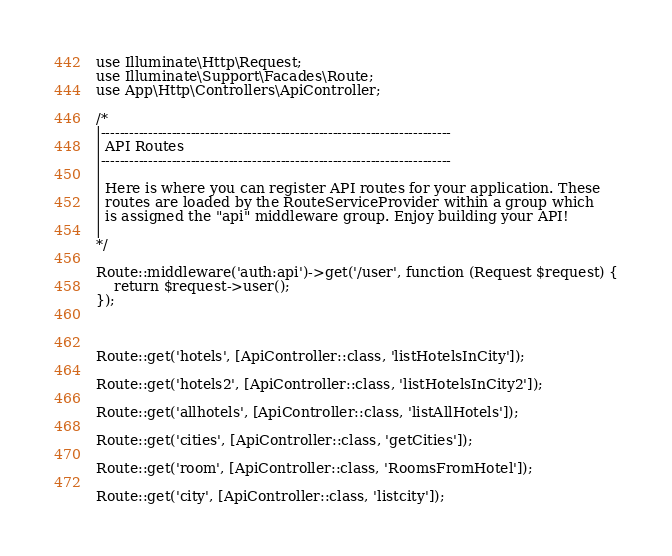Convert code to text. <code><loc_0><loc_0><loc_500><loc_500><_PHP_>
use Illuminate\Http\Request;
use Illuminate\Support\Facades\Route;
use App\Http\Controllers\ApiController;

/*
|--------------------------------------------------------------------------
| API Routes
|--------------------------------------------------------------------------
|
| Here is where you can register API routes for your application. These
| routes are loaded by the RouteServiceProvider within a group which
| is assigned the "api" middleware group. Enjoy building your API!
|
*/

Route::middleware('auth:api')->get('/user', function (Request $request) {
    return $request->user();
});



Route::get('hotels', [ApiController::class, 'listHotelsInCity']);

Route::get('hotels2', [ApiController::class, 'listHotelsInCity2']);

Route::get('allhotels', [ApiController::class, 'listAllHotels']);

Route::get('cities', [ApiController::class, 'getCities']);

Route::get('room', [ApiController::class, 'RoomsFromHotel']);

Route::get('city', [ApiController::class, 'listcity']);</code> 